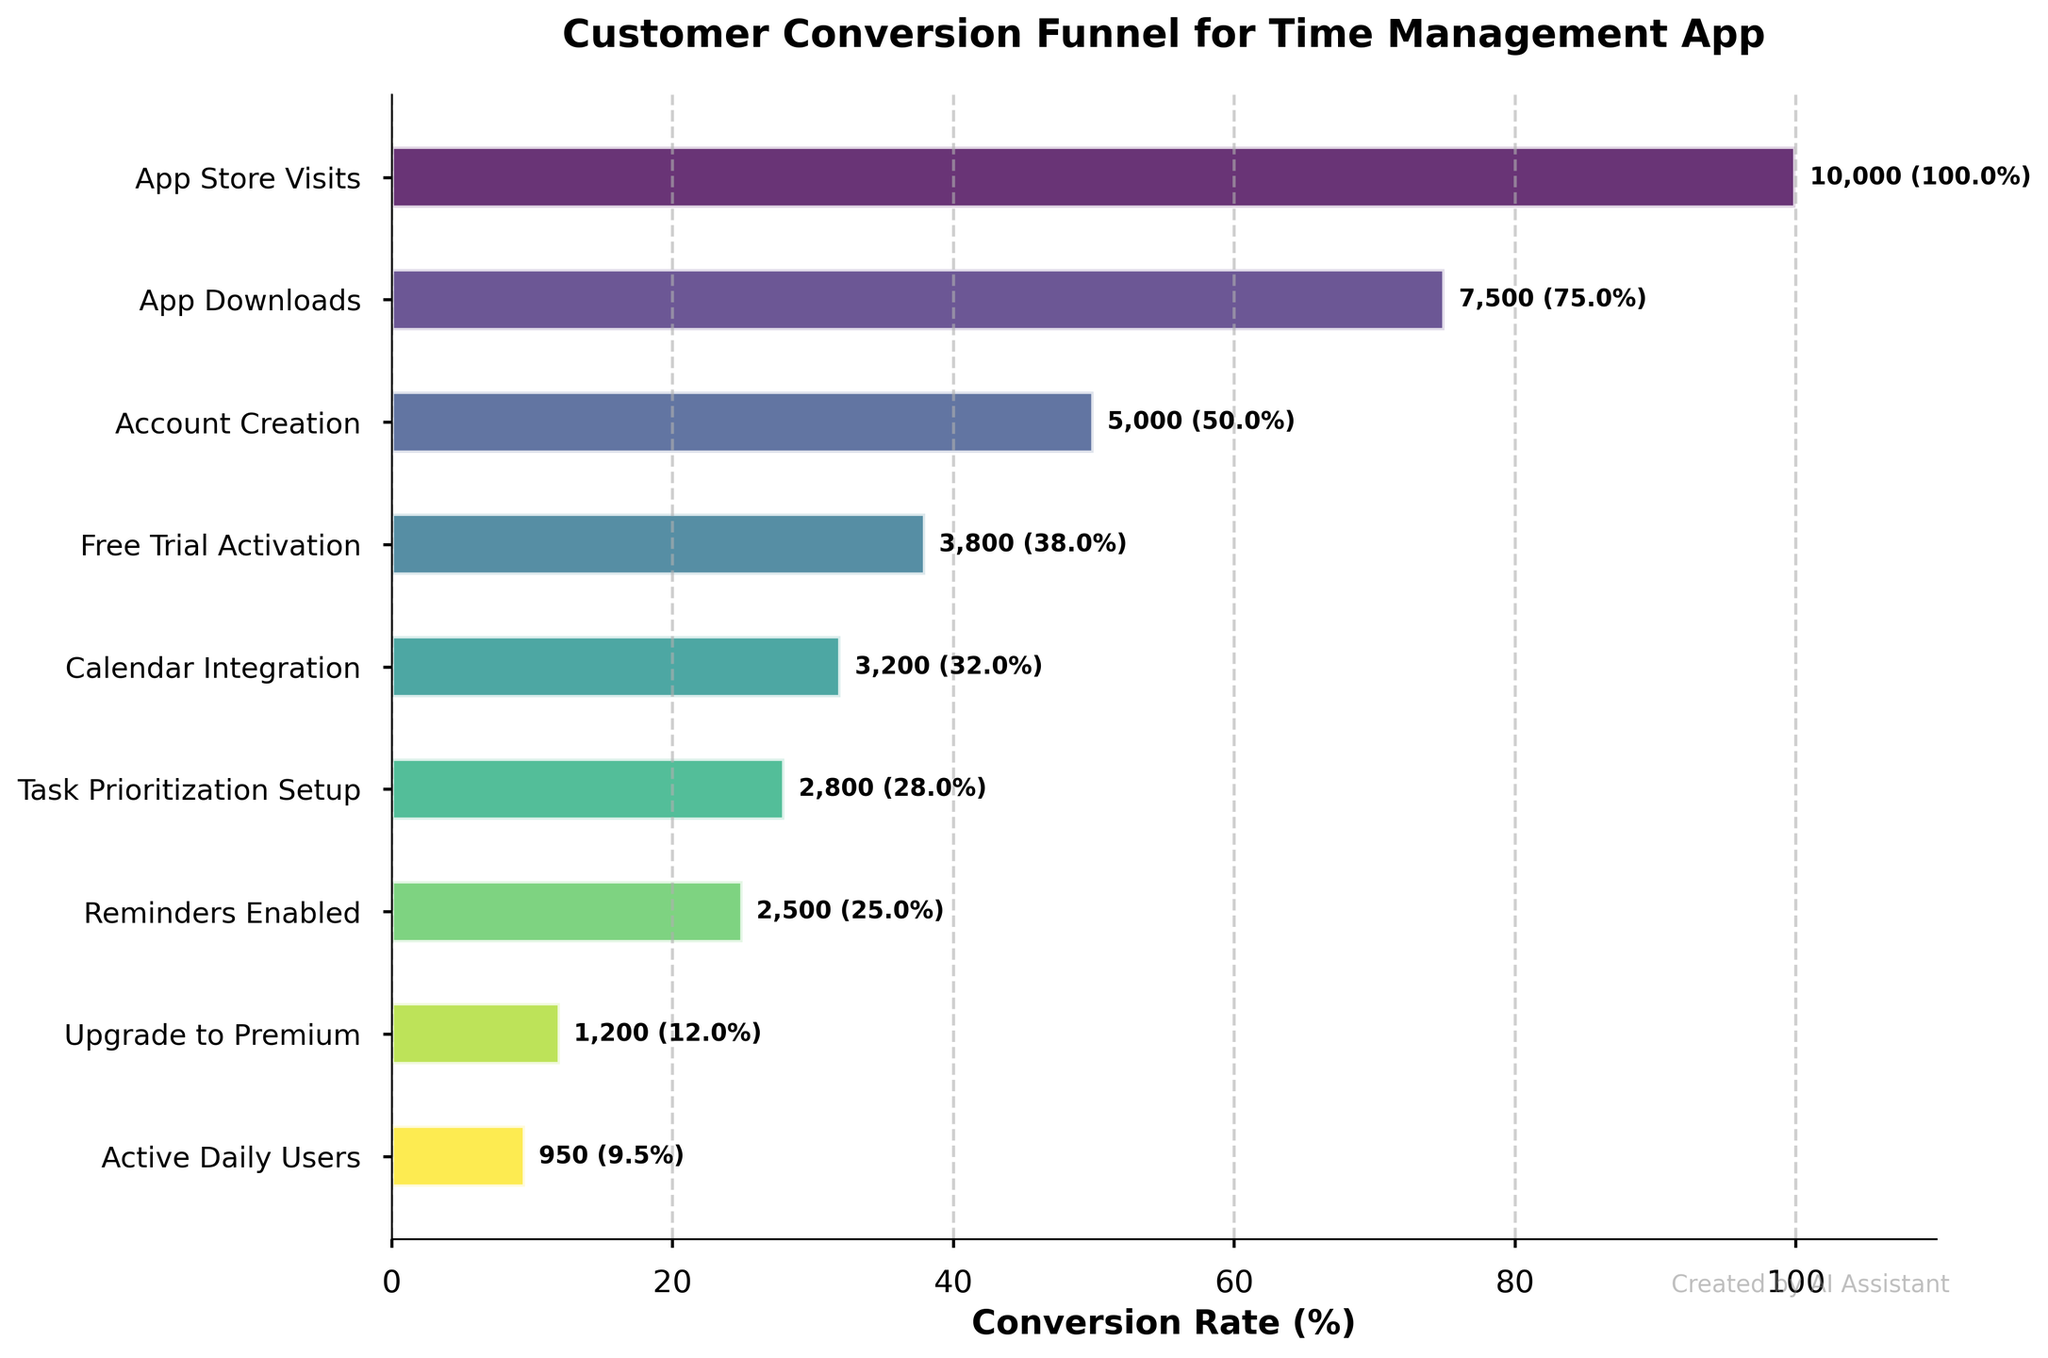What is the title of the figure? The title of the figure is located at the top of the chart and reads "Customer Conversion Funnel for Time Management App". This can be easily seen in the visual without any calculation or deeper inspection.
Answer: Customer Conversion Funnel for Time Management App What percentage of users who visit the app store end up upgrading to premium? Calculate the percentage of users who upgrade to premium out of the total app store visits. The total app store visits are 10,000 and the number of users who upgrade to premium is 1,200. The percentage is (1,200 / 10,000) * 100 = 12%.
Answer: 12% How many users enable reminders after setting up task prioritization? The number of users who enable reminders right after setting up task prioritization is given directly in the chart as 2,500. This value can be found by looking at the corresponding bar in the funnel.
Answer: 2,500 What is the drop-off rate between account creation and free trial activation? To find the drop-off rate between account creation and free trial activation, we need to subtract the number of users who activate free trials from those who create accounts, then divide by the number who create accounts, and multiply by 100 for the percentage. The calculation is ((5,000 - 3,800) / 5,000) * 100 = 24%.
Answer: 24% Compare the number of users who integrate their calendar versus those who upgrade to premium. Which is higher? The number of users who integrate their calendar is 3,200, whereas the number of users who upgrade to premium is 1,200. Therefore, there are more users integrating their calendar than upgrading to premium.
Answer: Calendar integration is higher What is the total number of users who remain active daily out of those who upgrade to premium? The chart shows that the number of users who upgrade to premium is 1,200, and out of these, 950 remain active daily. This indicates that out of the premium users, 950 continue to use the app actively.
Answer: 950 What percentage of users activate the free trial after downloading the app? To calculate this percentage, divide the number of users who activate the free trial (3,800) by the number of app downloads (7,500) and multiply by 100. The calculation is (3,800 / 7,500) * 100 = 50.67%.
Answer: 50.67% What is the difference in user count between those who create an account and those who set up task prioritization? The number of users who create an account is 5,000, and those who set up task prioritization is 2,800. The difference is 5,000 - 2,800 = 2,200.
Answer: 2,200 